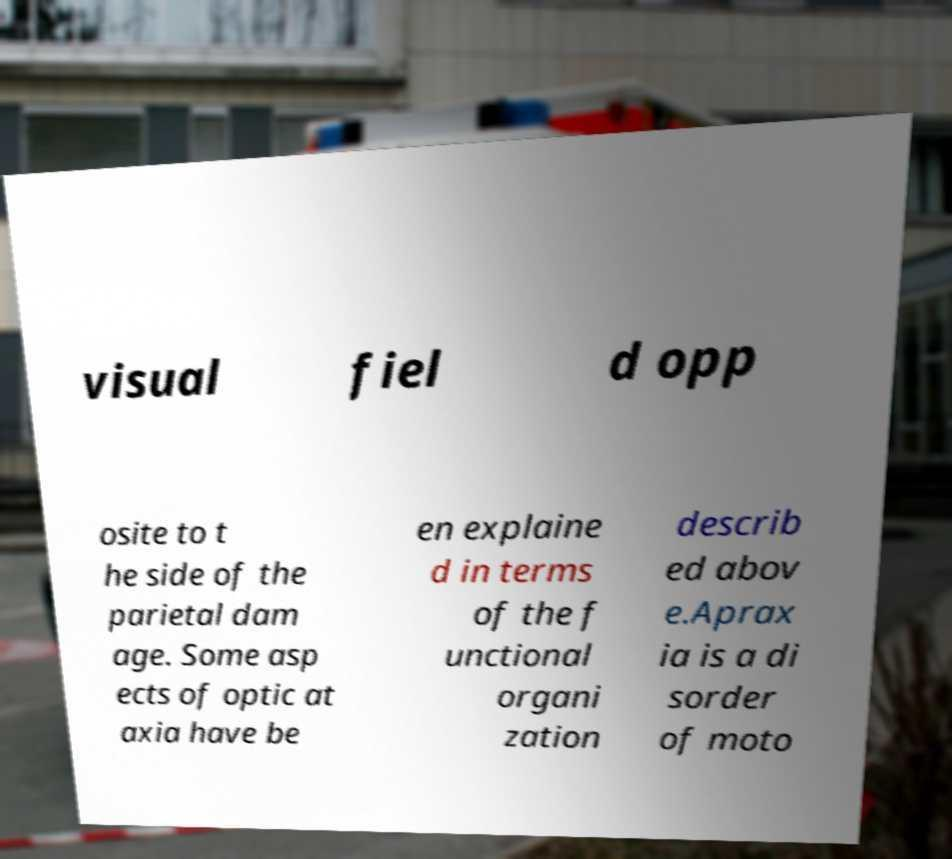Could you assist in decoding the text presented in this image and type it out clearly? visual fiel d opp osite to t he side of the parietal dam age. Some asp ects of optic at axia have be en explaine d in terms of the f unctional organi zation describ ed abov e.Aprax ia is a di sorder of moto 